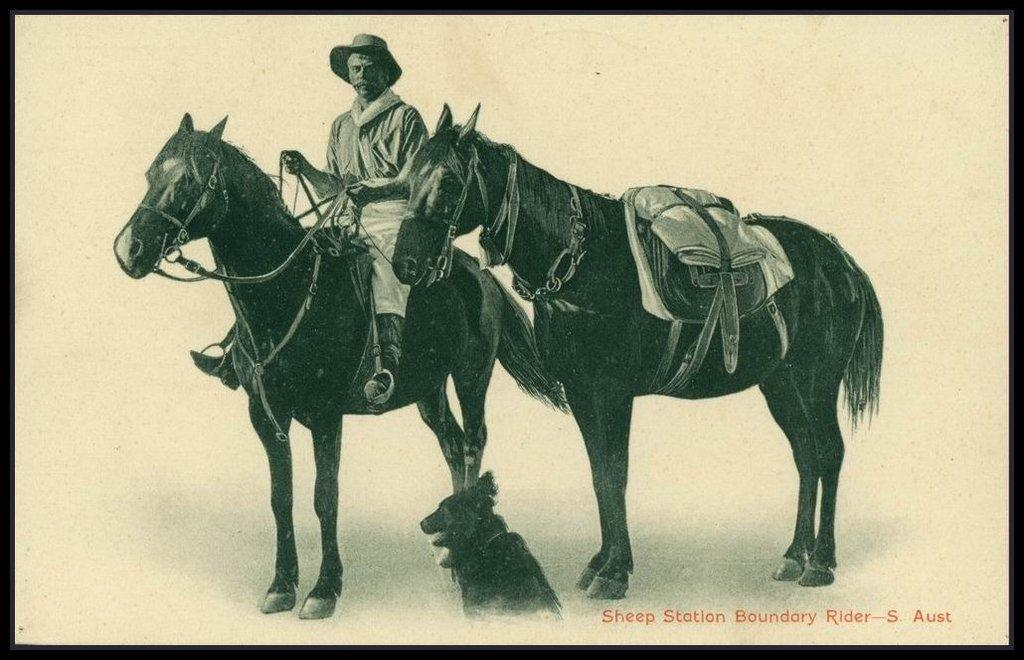How many horses are in the image? There are two horses in the image. What is the man in the image doing? A man is sitting on one of the horses. Can you describe the other animal in the image? There is a dog in the bottom right corner of the image. What else can be seen in the image besides the animals? There is text in the image. What type of bomb is being diffused by the man in the image? There is no bomb present in the image; it features two horses, a man sitting on one of them, a dog, and text. How many pets are visible in the image? There is only one pet visible in the image, which is the dog. 